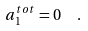Convert formula to latex. <formula><loc_0><loc_0><loc_500><loc_500>a _ { 1 } ^ { t o t } = 0 \, \ \ .</formula> 